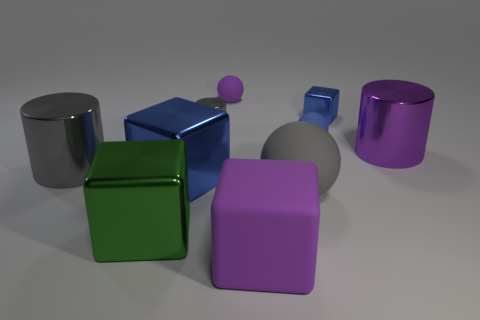What is the color of the big object that is the same shape as the tiny blue rubber thing?
Your answer should be compact. Gray. Is the number of small spheres that are in front of the large green shiny block less than the number of big gray shiny cylinders that are left of the large gray matte object?
Your answer should be very brief. Yes. What number of other objects are the same shape as the large green object?
Provide a succinct answer. 3. Is the number of large purple metallic objects that are behind the blue rubber object less than the number of yellow balls?
Keep it short and to the point. No. What is the purple object in front of the gray ball made of?
Offer a very short reply. Rubber. How many other things are the same size as the blue ball?
Your answer should be compact. 3. Are there fewer big purple metal things than blue shiny objects?
Offer a terse response. Yes. What is the shape of the big gray rubber thing?
Provide a succinct answer. Sphere. There is a small ball that is behind the small blue ball; is its color the same as the large matte cube?
Ensure brevity in your answer.  Yes. What shape is the metallic thing that is on the right side of the big blue block and left of the gray rubber object?
Provide a succinct answer. Cylinder. 